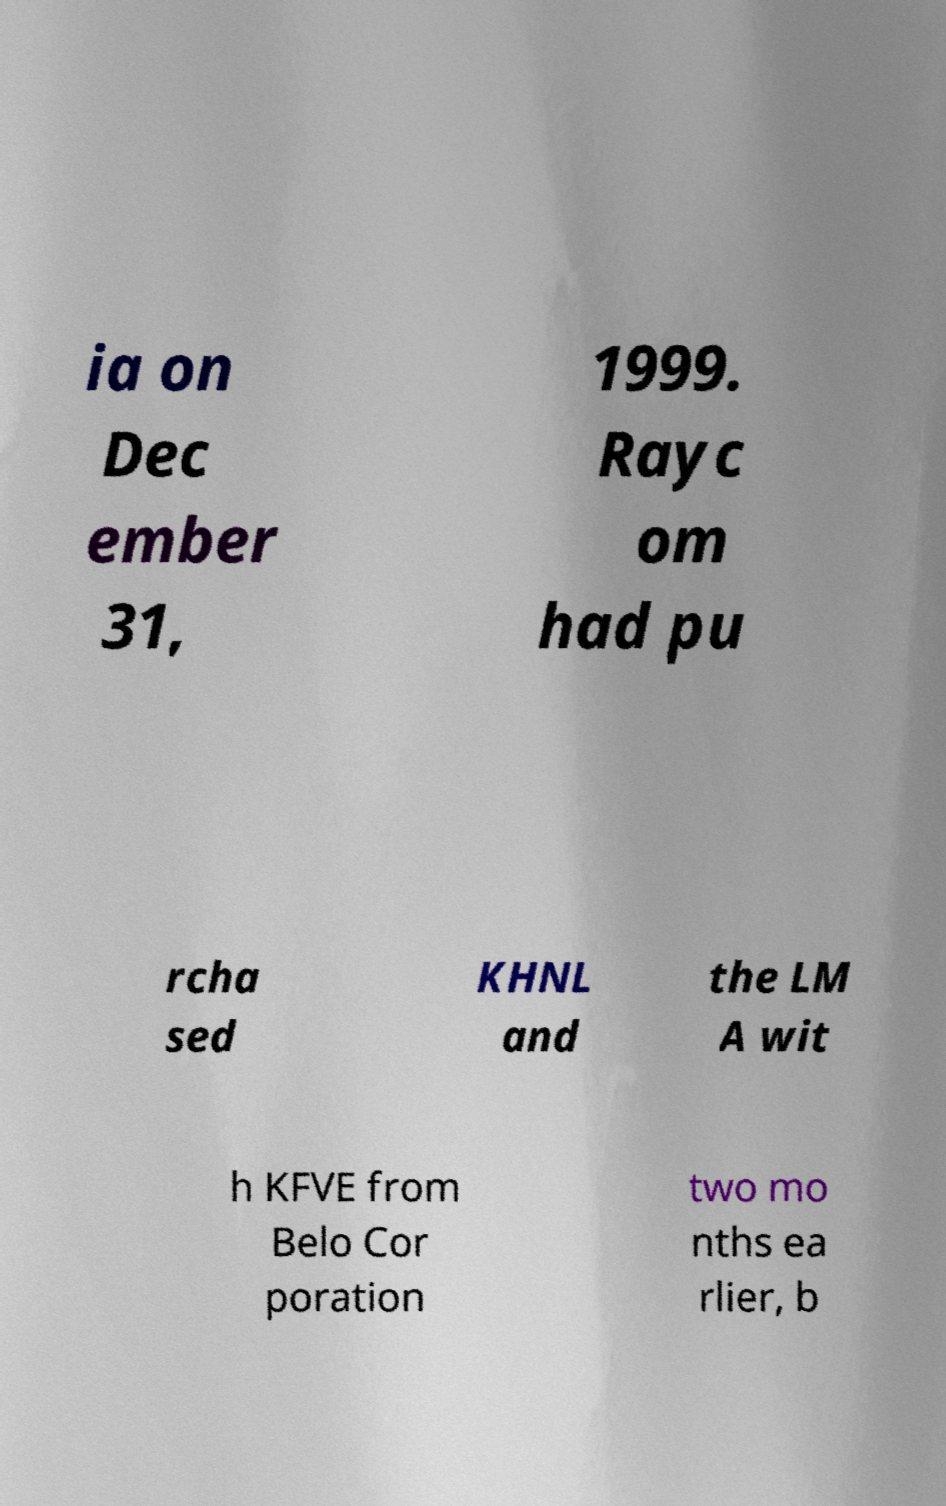What messages or text are displayed in this image? I need them in a readable, typed format. ia on Dec ember 31, 1999. Rayc om had pu rcha sed KHNL and the LM A wit h KFVE from Belo Cor poration two mo nths ea rlier, b 